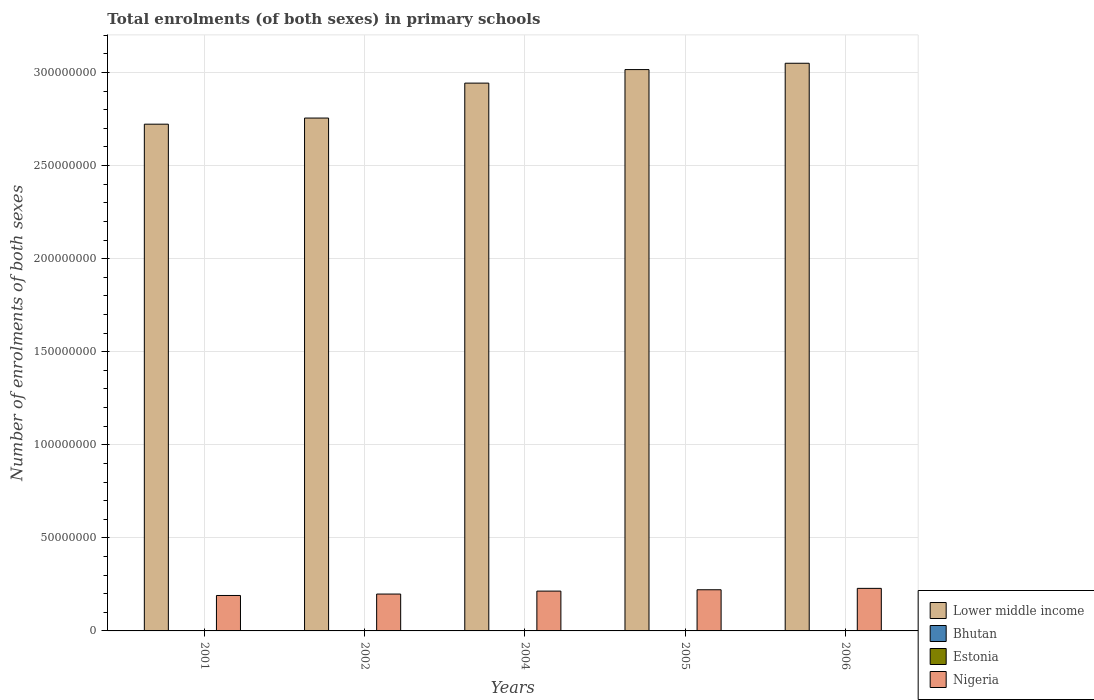Are the number of bars on each tick of the X-axis equal?
Give a very brief answer. Yes. How many bars are there on the 3rd tick from the left?
Provide a succinct answer. 4. What is the label of the 1st group of bars from the left?
Make the answer very short. 2001. What is the number of enrolments in primary schools in Estonia in 2004?
Offer a very short reply. 9.21e+04. Across all years, what is the maximum number of enrolments in primary schools in Lower middle income?
Provide a short and direct response. 3.05e+08. Across all years, what is the minimum number of enrolments in primary schools in Estonia?
Offer a very short reply. 7.96e+04. In which year was the number of enrolments in primary schools in Nigeria minimum?
Your answer should be compact. 2001. What is the total number of enrolments in primary schools in Nigeria in the graph?
Your answer should be compact. 1.05e+08. What is the difference between the number of enrolments in primary schools in Lower middle income in 2004 and that in 2006?
Offer a terse response. -1.07e+07. What is the difference between the number of enrolments in primary schools in Nigeria in 2001 and the number of enrolments in primary schools in Estonia in 2004?
Give a very brief answer. 1.89e+07. What is the average number of enrolments in primary schools in Estonia per year?
Provide a short and direct response. 9.66e+04. In the year 2004, what is the difference between the number of enrolments in primary schools in Estonia and number of enrolments in primary schools in Bhutan?
Your answer should be compact. -5225. In how many years, is the number of enrolments in primary schools in Bhutan greater than 270000000?
Ensure brevity in your answer.  0. What is the ratio of the number of enrolments in primary schools in Bhutan in 2001 to that in 2004?
Make the answer very short. 0.91. Is the difference between the number of enrolments in primary schools in Estonia in 2001 and 2002 greater than the difference between the number of enrolments in primary schools in Bhutan in 2001 and 2002?
Your answer should be very brief. Yes. What is the difference between the highest and the second highest number of enrolments in primary schools in Nigeria?
Your answer should be very brief. 7.46e+05. What is the difference between the highest and the lowest number of enrolments in primary schools in Nigeria?
Offer a very short reply. 3.82e+06. In how many years, is the number of enrolments in primary schools in Nigeria greater than the average number of enrolments in primary schools in Nigeria taken over all years?
Ensure brevity in your answer.  3. Is the sum of the number of enrolments in primary schools in Nigeria in 2002 and 2006 greater than the maximum number of enrolments in primary schools in Estonia across all years?
Provide a succinct answer. Yes. Is it the case that in every year, the sum of the number of enrolments in primary schools in Bhutan and number of enrolments in primary schools in Estonia is greater than the sum of number of enrolments in primary schools in Lower middle income and number of enrolments in primary schools in Nigeria?
Your response must be concise. Yes. What does the 4th bar from the left in 2004 represents?
Keep it short and to the point. Nigeria. What does the 4th bar from the right in 2005 represents?
Offer a terse response. Lower middle income. Is it the case that in every year, the sum of the number of enrolments in primary schools in Lower middle income and number of enrolments in primary schools in Bhutan is greater than the number of enrolments in primary schools in Estonia?
Make the answer very short. Yes. Are all the bars in the graph horizontal?
Provide a short and direct response. No. How many years are there in the graph?
Give a very brief answer. 5. Are the values on the major ticks of Y-axis written in scientific E-notation?
Your answer should be compact. No. Does the graph contain grids?
Give a very brief answer. Yes. How many legend labels are there?
Keep it short and to the point. 4. How are the legend labels stacked?
Your answer should be very brief. Vertical. What is the title of the graph?
Your answer should be compact. Total enrolments (of both sexes) in primary schools. What is the label or title of the X-axis?
Your answer should be very brief. Years. What is the label or title of the Y-axis?
Your answer should be compact. Number of enrolments of both sexes. What is the Number of enrolments of both sexes in Lower middle income in 2001?
Ensure brevity in your answer.  2.72e+08. What is the Number of enrolments of both sexes in Bhutan in 2001?
Provide a short and direct response. 8.82e+04. What is the Number of enrolments of both sexes in Estonia in 2001?
Offer a very short reply. 1.17e+05. What is the Number of enrolments of both sexes in Nigeria in 2001?
Offer a very short reply. 1.90e+07. What is the Number of enrolments of both sexes in Lower middle income in 2002?
Your response must be concise. 2.76e+08. What is the Number of enrolments of both sexes in Bhutan in 2002?
Ensure brevity in your answer.  9.09e+04. What is the Number of enrolments of both sexes in Estonia in 2002?
Make the answer very short. 1.09e+05. What is the Number of enrolments of both sexes in Nigeria in 2002?
Offer a very short reply. 1.98e+07. What is the Number of enrolments of both sexes in Lower middle income in 2004?
Provide a short and direct response. 2.94e+08. What is the Number of enrolments of both sexes of Bhutan in 2004?
Provide a succinct answer. 9.73e+04. What is the Number of enrolments of both sexes of Estonia in 2004?
Ensure brevity in your answer.  9.21e+04. What is the Number of enrolments of both sexes of Nigeria in 2004?
Keep it short and to the point. 2.14e+07. What is the Number of enrolments of both sexes of Lower middle income in 2005?
Your answer should be compact. 3.02e+08. What is the Number of enrolments of both sexes of Bhutan in 2005?
Your answer should be compact. 9.95e+04. What is the Number of enrolments of both sexes of Estonia in 2005?
Your answer should be compact. 8.55e+04. What is the Number of enrolments of both sexes in Nigeria in 2005?
Make the answer very short. 2.21e+07. What is the Number of enrolments of both sexes in Lower middle income in 2006?
Provide a succinct answer. 3.05e+08. What is the Number of enrolments of both sexes of Bhutan in 2006?
Your answer should be compact. 1.02e+05. What is the Number of enrolments of both sexes of Estonia in 2006?
Your response must be concise. 7.96e+04. What is the Number of enrolments of both sexes of Nigeria in 2006?
Provide a succinct answer. 2.29e+07. Across all years, what is the maximum Number of enrolments of both sexes of Lower middle income?
Provide a short and direct response. 3.05e+08. Across all years, what is the maximum Number of enrolments of both sexes of Bhutan?
Ensure brevity in your answer.  1.02e+05. Across all years, what is the maximum Number of enrolments of both sexes in Estonia?
Offer a terse response. 1.17e+05. Across all years, what is the maximum Number of enrolments of both sexes in Nigeria?
Provide a short and direct response. 2.29e+07. Across all years, what is the minimum Number of enrolments of both sexes of Lower middle income?
Offer a terse response. 2.72e+08. Across all years, what is the minimum Number of enrolments of both sexes in Bhutan?
Provide a succinct answer. 8.82e+04. Across all years, what is the minimum Number of enrolments of both sexes of Estonia?
Make the answer very short. 7.96e+04. Across all years, what is the minimum Number of enrolments of both sexes in Nigeria?
Make the answer very short. 1.90e+07. What is the total Number of enrolments of both sexes in Lower middle income in the graph?
Your answer should be very brief. 1.45e+09. What is the total Number of enrolments of both sexes in Bhutan in the graph?
Give a very brief answer. 4.78e+05. What is the total Number of enrolments of both sexes in Estonia in the graph?
Offer a very short reply. 4.83e+05. What is the total Number of enrolments of both sexes in Nigeria in the graph?
Offer a terse response. 1.05e+08. What is the difference between the Number of enrolments of both sexes in Lower middle income in 2001 and that in 2002?
Provide a short and direct response. -3.29e+06. What is the difference between the Number of enrolments of both sexes in Bhutan in 2001 and that in 2002?
Ensure brevity in your answer.  -2740. What is the difference between the Number of enrolments of both sexes in Estonia in 2001 and that in 2002?
Offer a very short reply. 8652. What is the difference between the Number of enrolments of both sexes in Nigeria in 2001 and that in 2002?
Your answer should be compact. -7.65e+05. What is the difference between the Number of enrolments of both sexes in Lower middle income in 2001 and that in 2004?
Your answer should be very brief. -2.21e+07. What is the difference between the Number of enrolments of both sexes in Bhutan in 2001 and that in 2004?
Ensure brevity in your answer.  -9119. What is the difference between the Number of enrolments of both sexes in Estonia in 2001 and that in 2004?
Give a very brief answer. 2.52e+04. What is the difference between the Number of enrolments of both sexes in Nigeria in 2001 and that in 2004?
Your response must be concise. -2.35e+06. What is the difference between the Number of enrolments of both sexes in Lower middle income in 2001 and that in 2005?
Your answer should be compact. -2.93e+07. What is the difference between the Number of enrolments of both sexes in Bhutan in 2001 and that in 2005?
Offer a very short reply. -1.13e+04. What is the difference between the Number of enrolments of both sexes in Estonia in 2001 and that in 2005?
Ensure brevity in your answer.  3.18e+04. What is the difference between the Number of enrolments of both sexes of Nigeria in 2001 and that in 2005?
Your answer should be compact. -3.07e+06. What is the difference between the Number of enrolments of both sexes of Lower middle income in 2001 and that in 2006?
Offer a terse response. -3.27e+07. What is the difference between the Number of enrolments of both sexes in Bhutan in 2001 and that in 2006?
Offer a very short reply. -1.40e+04. What is the difference between the Number of enrolments of both sexes of Estonia in 2001 and that in 2006?
Your response must be concise. 3.77e+04. What is the difference between the Number of enrolments of both sexes of Nigeria in 2001 and that in 2006?
Make the answer very short. -3.82e+06. What is the difference between the Number of enrolments of both sexes of Lower middle income in 2002 and that in 2004?
Your answer should be compact. -1.88e+07. What is the difference between the Number of enrolments of both sexes of Bhutan in 2002 and that in 2004?
Your answer should be compact. -6379. What is the difference between the Number of enrolments of both sexes of Estonia in 2002 and that in 2004?
Make the answer very short. 1.65e+04. What is the difference between the Number of enrolments of both sexes in Nigeria in 2002 and that in 2004?
Make the answer very short. -1.59e+06. What is the difference between the Number of enrolments of both sexes of Lower middle income in 2002 and that in 2005?
Keep it short and to the point. -2.60e+07. What is the difference between the Number of enrolments of both sexes of Bhutan in 2002 and that in 2005?
Provide a succinct answer. -8514. What is the difference between the Number of enrolments of both sexes of Estonia in 2002 and that in 2005?
Provide a short and direct response. 2.31e+04. What is the difference between the Number of enrolments of both sexes in Nigeria in 2002 and that in 2005?
Provide a succinct answer. -2.31e+06. What is the difference between the Number of enrolments of both sexes in Lower middle income in 2002 and that in 2006?
Keep it short and to the point. -2.94e+07. What is the difference between the Number of enrolments of both sexes in Bhutan in 2002 and that in 2006?
Your answer should be very brief. -1.13e+04. What is the difference between the Number of enrolments of both sexes of Estonia in 2002 and that in 2006?
Ensure brevity in your answer.  2.90e+04. What is the difference between the Number of enrolments of both sexes of Nigeria in 2002 and that in 2006?
Provide a short and direct response. -3.06e+06. What is the difference between the Number of enrolments of both sexes of Lower middle income in 2004 and that in 2005?
Offer a very short reply. -7.27e+06. What is the difference between the Number of enrolments of both sexes of Bhutan in 2004 and that in 2005?
Keep it short and to the point. -2135. What is the difference between the Number of enrolments of both sexes of Estonia in 2004 and that in 2005?
Provide a succinct answer. 6559. What is the difference between the Number of enrolments of both sexes of Nigeria in 2004 and that in 2005?
Your answer should be very brief. -7.20e+05. What is the difference between the Number of enrolments of both sexes of Lower middle income in 2004 and that in 2006?
Offer a terse response. -1.07e+07. What is the difference between the Number of enrolments of both sexes in Bhutan in 2004 and that in 2006?
Keep it short and to the point. -4902. What is the difference between the Number of enrolments of both sexes in Estonia in 2004 and that in 2006?
Ensure brevity in your answer.  1.25e+04. What is the difference between the Number of enrolments of both sexes in Nigeria in 2004 and that in 2006?
Keep it short and to the point. -1.47e+06. What is the difference between the Number of enrolments of both sexes in Lower middle income in 2005 and that in 2006?
Offer a very short reply. -3.40e+06. What is the difference between the Number of enrolments of both sexes of Bhutan in 2005 and that in 2006?
Give a very brief answer. -2767. What is the difference between the Number of enrolments of both sexes of Estonia in 2005 and that in 2006?
Your answer should be compact. 5950. What is the difference between the Number of enrolments of both sexes in Nigeria in 2005 and that in 2006?
Provide a succinct answer. -7.46e+05. What is the difference between the Number of enrolments of both sexes of Lower middle income in 2001 and the Number of enrolments of both sexes of Bhutan in 2002?
Offer a very short reply. 2.72e+08. What is the difference between the Number of enrolments of both sexes of Lower middle income in 2001 and the Number of enrolments of both sexes of Estonia in 2002?
Your answer should be compact. 2.72e+08. What is the difference between the Number of enrolments of both sexes of Lower middle income in 2001 and the Number of enrolments of both sexes of Nigeria in 2002?
Offer a very short reply. 2.52e+08. What is the difference between the Number of enrolments of both sexes in Bhutan in 2001 and the Number of enrolments of both sexes in Estonia in 2002?
Your response must be concise. -2.04e+04. What is the difference between the Number of enrolments of both sexes of Bhutan in 2001 and the Number of enrolments of both sexes of Nigeria in 2002?
Provide a short and direct response. -1.97e+07. What is the difference between the Number of enrolments of both sexes in Estonia in 2001 and the Number of enrolments of both sexes in Nigeria in 2002?
Keep it short and to the point. -1.97e+07. What is the difference between the Number of enrolments of both sexes of Lower middle income in 2001 and the Number of enrolments of both sexes of Bhutan in 2004?
Provide a short and direct response. 2.72e+08. What is the difference between the Number of enrolments of both sexes in Lower middle income in 2001 and the Number of enrolments of both sexes in Estonia in 2004?
Provide a short and direct response. 2.72e+08. What is the difference between the Number of enrolments of both sexes in Lower middle income in 2001 and the Number of enrolments of both sexes in Nigeria in 2004?
Give a very brief answer. 2.51e+08. What is the difference between the Number of enrolments of both sexes in Bhutan in 2001 and the Number of enrolments of both sexes in Estonia in 2004?
Give a very brief answer. -3894. What is the difference between the Number of enrolments of both sexes of Bhutan in 2001 and the Number of enrolments of both sexes of Nigeria in 2004?
Make the answer very short. -2.13e+07. What is the difference between the Number of enrolments of both sexes of Estonia in 2001 and the Number of enrolments of both sexes of Nigeria in 2004?
Make the answer very short. -2.13e+07. What is the difference between the Number of enrolments of both sexes in Lower middle income in 2001 and the Number of enrolments of both sexes in Bhutan in 2005?
Your answer should be very brief. 2.72e+08. What is the difference between the Number of enrolments of both sexes in Lower middle income in 2001 and the Number of enrolments of both sexes in Estonia in 2005?
Make the answer very short. 2.72e+08. What is the difference between the Number of enrolments of both sexes of Lower middle income in 2001 and the Number of enrolments of both sexes of Nigeria in 2005?
Ensure brevity in your answer.  2.50e+08. What is the difference between the Number of enrolments of both sexes of Bhutan in 2001 and the Number of enrolments of both sexes of Estonia in 2005?
Provide a succinct answer. 2665. What is the difference between the Number of enrolments of both sexes in Bhutan in 2001 and the Number of enrolments of both sexes in Nigeria in 2005?
Your answer should be compact. -2.20e+07. What is the difference between the Number of enrolments of both sexes in Estonia in 2001 and the Number of enrolments of both sexes in Nigeria in 2005?
Your response must be concise. -2.20e+07. What is the difference between the Number of enrolments of both sexes in Lower middle income in 2001 and the Number of enrolments of both sexes in Bhutan in 2006?
Keep it short and to the point. 2.72e+08. What is the difference between the Number of enrolments of both sexes of Lower middle income in 2001 and the Number of enrolments of both sexes of Estonia in 2006?
Your answer should be very brief. 2.72e+08. What is the difference between the Number of enrolments of both sexes of Lower middle income in 2001 and the Number of enrolments of both sexes of Nigeria in 2006?
Offer a terse response. 2.49e+08. What is the difference between the Number of enrolments of both sexes of Bhutan in 2001 and the Number of enrolments of both sexes of Estonia in 2006?
Give a very brief answer. 8615. What is the difference between the Number of enrolments of both sexes of Bhutan in 2001 and the Number of enrolments of both sexes of Nigeria in 2006?
Give a very brief answer. -2.28e+07. What is the difference between the Number of enrolments of both sexes in Estonia in 2001 and the Number of enrolments of both sexes in Nigeria in 2006?
Your answer should be very brief. -2.27e+07. What is the difference between the Number of enrolments of both sexes in Lower middle income in 2002 and the Number of enrolments of both sexes in Bhutan in 2004?
Provide a succinct answer. 2.75e+08. What is the difference between the Number of enrolments of both sexes in Lower middle income in 2002 and the Number of enrolments of both sexes in Estonia in 2004?
Offer a terse response. 2.75e+08. What is the difference between the Number of enrolments of both sexes of Lower middle income in 2002 and the Number of enrolments of both sexes of Nigeria in 2004?
Your answer should be compact. 2.54e+08. What is the difference between the Number of enrolments of both sexes in Bhutan in 2002 and the Number of enrolments of both sexes in Estonia in 2004?
Give a very brief answer. -1154. What is the difference between the Number of enrolments of both sexes in Bhutan in 2002 and the Number of enrolments of both sexes in Nigeria in 2004?
Offer a very short reply. -2.13e+07. What is the difference between the Number of enrolments of both sexes in Estonia in 2002 and the Number of enrolments of both sexes in Nigeria in 2004?
Ensure brevity in your answer.  -2.13e+07. What is the difference between the Number of enrolments of both sexes of Lower middle income in 2002 and the Number of enrolments of both sexes of Bhutan in 2005?
Offer a terse response. 2.75e+08. What is the difference between the Number of enrolments of both sexes in Lower middle income in 2002 and the Number of enrolments of both sexes in Estonia in 2005?
Ensure brevity in your answer.  2.75e+08. What is the difference between the Number of enrolments of both sexes of Lower middle income in 2002 and the Number of enrolments of both sexes of Nigeria in 2005?
Offer a terse response. 2.53e+08. What is the difference between the Number of enrolments of both sexes of Bhutan in 2002 and the Number of enrolments of both sexes of Estonia in 2005?
Ensure brevity in your answer.  5405. What is the difference between the Number of enrolments of both sexes of Bhutan in 2002 and the Number of enrolments of both sexes of Nigeria in 2005?
Give a very brief answer. -2.20e+07. What is the difference between the Number of enrolments of both sexes of Estonia in 2002 and the Number of enrolments of both sexes of Nigeria in 2005?
Your response must be concise. -2.20e+07. What is the difference between the Number of enrolments of both sexes of Lower middle income in 2002 and the Number of enrolments of both sexes of Bhutan in 2006?
Keep it short and to the point. 2.75e+08. What is the difference between the Number of enrolments of both sexes in Lower middle income in 2002 and the Number of enrolments of both sexes in Estonia in 2006?
Your answer should be very brief. 2.75e+08. What is the difference between the Number of enrolments of both sexes in Lower middle income in 2002 and the Number of enrolments of both sexes in Nigeria in 2006?
Your answer should be compact. 2.53e+08. What is the difference between the Number of enrolments of both sexes in Bhutan in 2002 and the Number of enrolments of both sexes in Estonia in 2006?
Offer a terse response. 1.14e+04. What is the difference between the Number of enrolments of both sexes of Bhutan in 2002 and the Number of enrolments of both sexes of Nigeria in 2006?
Give a very brief answer. -2.28e+07. What is the difference between the Number of enrolments of both sexes of Estonia in 2002 and the Number of enrolments of both sexes of Nigeria in 2006?
Ensure brevity in your answer.  -2.28e+07. What is the difference between the Number of enrolments of both sexes in Lower middle income in 2004 and the Number of enrolments of both sexes in Bhutan in 2005?
Make the answer very short. 2.94e+08. What is the difference between the Number of enrolments of both sexes in Lower middle income in 2004 and the Number of enrolments of both sexes in Estonia in 2005?
Ensure brevity in your answer.  2.94e+08. What is the difference between the Number of enrolments of both sexes of Lower middle income in 2004 and the Number of enrolments of both sexes of Nigeria in 2005?
Your answer should be very brief. 2.72e+08. What is the difference between the Number of enrolments of both sexes in Bhutan in 2004 and the Number of enrolments of both sexes in Estonia in 2005?
Provide a short and direct response. 1.18e+04. What is the difference between the Number of enrolments of both sexes of Bhutan in 2004 and the Number of enrolments of both sexes of Nigeria in 2005?
Give a very brief answer. -2.20e+07. What is the difference between the Number of enrolments of both sexes of Estonia in 2004 and the Number of enrolments of both sexes of Nigeria in 2005?
Provide a succinct answer. -2.20e+07. What is the difference between the Number of enrolments of both sexes in Lower middle income in 2004 and the Number of enrolments of both sexes in Bhutan in 2006?
Your answer should be very brief. 2.94e+08. What is the difference between the Number of enrolments of both sexes in Lower middle income in 2004 and the Number of enrolments of both sexes in Estonia in 2006?
Your answer should be very brief. 2.94e+08. What is the difference between the Number of enrolments of both sexes in Lower middle income in 2004 and the Number of enrolments of both sexes in Nigeria in 2006?
Make the answer very short. 2.71e+08. What is the difference between the Number of enrolments of both sexes of Bhutan in 2004 and the Number of enrolments of both sexes of Estonia in 2006?
Give a very brief answer. 1.77e+04. What is the difference between the Number of enrolments of both sexes of Bhutan in 2004 and the Number of enrolments of both sexes of Nigeria in 2006?
Your answer should be very brief. -2.28e+07. What is the difference between the Number of enrolments of both sexes in Estonia in 2004 and the Number of enrolments of both sexes in Nigeria in 2006?
Your response must be concise. -2.28e+07. What is the difference between the Number of enrolments of both sexes in Lower middle income in 2005 and the Number of enrolments of both sexes in Bhutan in 2006?
Make the answer very short. 3.01e+08. What is the difference between the Number of enrolments of both sexes of Lower middle income in 2005 and the Number of enrolments of both sexes of Estonia in 2006?
Provide a short and direct response. 3.02e+08. What is the difference between the Number of enrolments of both sexes in Lower middle income in 2005 and the Number of enrolments of both sexes in Nigeria in 2006?
Offer a terse response. 2.79e+08. What is the difference between the Number of enrolments of both sexes of Bhutan in 2005 and the Number of enrolments of both sexes of Estonia in 2006?
Your answer should be very brief. 1.99e+04. What is the difference between the Number of enrolments of both sexes in Bhutan in 2005 and the Number of enrolments of both sexes in Nigeria in 2006?
Your answer should be compact. -2.28e+07. What is the difference between the Number of enrolments of both sexes in Estonia in 2005 and the Number of enrolments of both sexes in Nigeria in 2006?
Give a very brief answer. -2.28e+07. What is the average Number of enrolments of both sexes of Lower middle income per year?
Your answer should be very brief. 2.90e+08. What is the average Number of enrolments of both sexes in Bhutan per year?
Provide a succinct answer. 9.56e+04. What is the average Number of enrolments of both sexes of Estonia per year?
Give a very brief answer. 9.66e+04. What is the average Number of enrolments of both sexes in Nigeria per year?
Give a very brief answer. 2.10e+07. In the year 2001, what is the difference between the Number of enrolments of both sexes of Lower middle income and Number of enrolments of both sexes of Bhutan?
Offer a terse response. 2.72e+08. In the year 2001, what is the difference between the Number of enrolments of both sexes in Lower middle income and Number of enrolments of both sexes in Estonia?
Your response must be concise. 2.72e+08. In the year 2001, what is the difference between the Number of enrolments of both sexes of Lower middle income and Number of enrolments of both sexes of Nigeria?
Your answer should be compact. 2.53e+08. In the year 2001, what is the difference between the Number of enrolments of both sexes of Bhutan and Number of enrolments of both sexes of Estonia?
Provide a short and direct response. -2.91e+04. In the year 2001, what is the difference between the Number of enrolments of both sexes of Bhutan and Number of enrolments of both sexes of Nigeria?
Make the answer very short. -1.90e+07. In the year 2001, what is the difference between the Number of enrolments of both sexes in Estonia and Number of enrolments of both sexes in Nigeria?
Your answer should be compact. -1.89e+07. In the year 2002, what is the difference between the Number of enrolments of both sexes of Lower middle income and Number of enrolments of both sexes of Bhutan?
Offer a very short reply. 2.75e+08. In the year 2002, what is the difference between the Number of enrolments of both sexes in Lower middle income and Number of enrolments of both sexes in Estonia?
Give a very brief answer. 2.75e+08. In the year 2002, what is the difference between the Number of enrolments of both sexes in Lower middle income and Number of enrolments of both sexes in Nigeria?
Offer a very short reply. 2.56e+08. In the year 2002, what is the difference between the Number of enrolments of both sexes of Bhutan and Number of enrolments of both sexes of Estonia?
Give a very brief answer. -1.77e+04. In the year 2002, what is the difference between the Number of enrolments of both sexes of Bhutan and Number of enrolments of both sexes of Nigeria?
Provide a succinct answer. -1.97e+07. In the year 2002, what is the difference between the Number of enrolments of both sexes of Estonia and Number of enrolments of both sexes of Nigeria?
Your answer should be compact. -1.97e+07. In the year 2004, what is the difference between the Number of enrolments of both sexes in Lower middle income and Number of enrolments of both sexes in Bhutan?
Offer a terse response. 2.94e+08. In the year 2004, what is the difference between the Number of enrolments of both sexes of Lower middle income and Number of enrolments of both sexes of Estonia?
Your response must be concise. 2.94e+08. In the year 2004, what is the difference between the Number of enrolments of both sexes in Lower middle income and Number of enrolments of both sexes in Nigeria?
Your answer should be compact. 2.73e+08. In the year 2004, what is the difference between the Number of enrolments of both sexes in Bhutan and Number of enrolments of both sexes in Estonia?
Provide a succinct answer. 5225. In the year 2004, what is the difference between the Number of enrolments of both sexes of Bhutan and Number of enrolments of both sexes of Nigeria?
Your answer should be compact. -2.13e+07. In the year 2004, what is the difference between the Number of enrolments of both sexes of Estonia and Number of enrolments of both sexes of Nigeria?
Provide a short and direct response. -2.13e+07. In the year 2005, what is the difference between the Number of enrolments of both sexes of Lower middle income and Number of enrolments of both sexes of Bhutan?
Your answer should be compact. 3.01e+08. In the year 2005, what is the difference between the Number of enrolments of both sexes in Lower middle income and Number of enrolments of both sexes in Estonia?
Give a very brief answer. 3.02e+08. In the year 2005, what is the difference between the Number of enrolments of both sexes in Lower middle income and Number of enrolments of both sexes in Nigeria?
Ensure brevity in your answer.  2.79e+08. In the year 2005, what is the difference between the Number of enrolments of both sexes of Bhutan and Number of enrolments of both sexes of Estonia?
Keep it short and to the point. 1.39e+04. In the year 2005, what is the difference between the Number of enrolments of both sexes in Bhutan and Number of enrolments of both sexes in Nigeria?
Offer a very short reply. -2.20e+07. In the year 2005, what is the difference between the Number of enrolments of both sexes in Estonia and Number of enrolments of both sexes in Nigeria?
Your answer should be very brief. -2.20e+07. In the year 2006, what is the difference between the Number of enrolments of both sexes of Lower middle income and Number of enrolments of both sexes of Bhutan?
Your answer should be very brief. 3.05e+08. In the year 2006, what is the difference between the Number of enrolments of both sexes in Lower middle income and Number of enrolments of both sexes in Estonia?
Your answer should be compact. 3.05e+08. In the year 2006, what is the difference between the Number of enrolments of both sexes in Lower middle income and Number of enrolments of both sexes in Nigeria?
Keep it short and to the point. 2.82e+08. In the year 2006, what is the difference between the Number of enrolments of both sexes of Bhutan and Number of enrolments of both sexes of Estonia?
Provide a short and direct response. 2.26e+04. In the year 2006, what is the difference between the Number of enrolments of both sexes of Bhutan and Number of enrolments of both sexes of Nigeria?
Offer a terse response. -2.28e+07. In the year 2006, what is the difference between the Number of enrolments of both sexes in Estonia and Number of enrolments of both sexes in Nigeria?
Make the answer very short. -2.28e+07. What is the ratio of the Number of enrolments of both sexes of Bhutan in 2001 to that in 2002?
Make the answer very short. 0.97. What is the ratio of the Number of enrolments of both sexes of Estonia in 2001 to that in 2002?
Offer a very short reply. 1.08. What is the ratio of the Number of enrolments of both sexes of Nigeria in 2001 to that in 2002?
Make the answer very short. 0.96. What is the ratio of the Number of enrolments of both sexes of Lower middle income in 2001 to that in 2004?
Provide a succinct answer. 0.93. What is the ratio of the Number of enrolments of both sexes of Bhutan in 2001 to that in 2004?
Offer a terse response. 0.91. What is the ratio of the Number of enrolments of both sexes of Estonia in 2001 to that in 2004?
Your response must be concise. 1.27. What is the ratio of the Number of enrolments of both sexes of Nigeria in 2001 to that in 2004?
Your answer should be compact. 0.89. What is the ratio of the Number of enrolments of both sexes in Lower middle income in 2001 to that in 2005?
Make the answer very short. 0.9. What is the ratio of the Number of enrolments of both sexes in Bhutan in 2001 to that in 2005?
Ensure brevity in your answer.  0.89. What is the ratio of the Number of enrolments of both sexes of Estonia in 2001 to that in 2005?
Keep it short and to the point. 1.37. What is the ratio of the Number of enrolments of both sexes of Nigeria in 2001 to that in 2005?
Your answer should be compact. 0.86. What is the ratio of the Number of enrolments of both sexes in Lower middle income in 2001 to that in 2006?
Provide a short and direct response. 0.89. What is the ratio of the Number of enrolments of both sexes in Bhutan in 2001 to that in 2006?
Ensure brevity in your answer.  0.86. What is the ratio of the Number of enrolments of both sexes in Estonia in 2001 to that in 2006?
Provide a short and direct response. 1.47. What is the ratio of the Number of enrolments of both sexes of Nigeria in 2001 to that in 2006?
Your response must be concise. 0.83. What is the ratio of the Number of enrolments of both sexes in Lower middle income in 2002 to that in 2004?
Your answer should be very brief. 0.94. What is the ratio of the Number of enrolments of both sexes of Bhutan in 2002 to that in 2004?
Make the answer very short. 0.93. What is the ratio of the Number of enrolments of both sexes of Estonia in 2002 to that in 2004?
Offer a terse response. 1.18. What is the ratio of the Number of enrolments of both sexes of Nigeria in 2002 to that in 2004?
Give a very brief answer. 0.93. What is the ratio of the Number of enrolments of both sexes of Lower middle income in 2002 to that in 2005?
Offer a terse response. 0.91. What is the ratio of the Number of enrolments of both sexes in Bhutan in 2002 to that in 2005?
Your answer should be compact. 0.91. What is the ratio of the Number of enrolments of both sexes in Estonia in 2002 to that in 2005?
Offer a very short reply. 1.27. What is the ratio of the Number of enrolments of both sexes of Nigeria in 2002 to that in 2005?
Give a very brief answer. 0.9. What is the ratio of the Number of enrolments of both sexes in Lower middle income in 2002 to that in 2006?
Your answer should be compact. 0.9. What is the ratio of the Number of enrolments of both sexes of Bhutan in 2002 to that in 2006?
Provide a short and direct response. 0.89. What is the ratio of the Number of enrolments of both sexes in Estonia in 2002 to that in 2006?
Give a very brief answer. 1.36. What is the ratio of the Number of enrolments of both sexes of Nigeria in 2002 to that in 2006?
Give a very brief answer. 0.87. What is the ratio of the Number of enrolments of both sexes in Lower middle income in 2004 to that in 2005?
Give a very brief answer. 0.98. What is the ratio of the Number of enrolments of both sexes in Bhutan in 2004 to that in 2005?
Provide a short and direct response. 0.98. What is the ratio of the Number of enrolments of both sexes in Estonia in 2004 to that in 2005?
Your response must be concise. 1.08. What is the ratio of the Number of enrolments of both sexes of Nigeria in 2004 to that in 2005?
Offer a very short reply. 0.97. What is the ratio of the Number of enrolments of both sexes of Estonia in 2004 to that in 2006?
Give a very brief answer. 1.16. What is the ratio of the Number of enrolments of both sexes of Nigeria in 2004 to that in 2006?
Your answer should be very brief. 0.94. What is the ratio of the Number of enrolments of both sexes in Lower middle income in 2005 to that in 2006?
Your answer should be very brief. 0.99. What is the ratio of the Number of enrolments of both sexes of Bhutan in 2005 to that in 2006?
Keep it short and to the point. 0.97. What is the ratio of the Number of enrolments of both sexes of Estonia in 2005 to that in 2006?
Your answer should be compact. 1.07. What is the ratio of the Number of enrolments of both sexes in Nigeria in 2005 to that in 2006?
Your answer should be compact. 0.97. What is the difference between the highest and the second highest Number of enrolments of both sexes of Lower middle income?
Offer a terse response. 3.40e+06. What is the difference between the highest and the second highest Number of enrolments of both sexes in Bhutan?
Your answer should be compact. 2767. What is the difference between the highest and the second highest Number of enrolments of both sexes of Estonia?
Provide a succinct answer. 8652. What is the difference between the highest and the second highest Number of enrolments of both sexes in Nigeria?
Ensure brevity in your answer.  7.46e+05. What is the difference between the highest and the lowest Number of enrolments of both sexes of Lower middle income?
Make the answer very short. 3.27e+07. What is the difference between the highest and the lowest Number of enrolments of both sexes of Bhutan?
Make the answer very short. 1.40e+04. What is the difference between the highest and the lowest Number of enrolments of both sexes of Estonia?
Keep it short and to the point. 3.77e+04. What is the difference between the highest and the lowest Number of enrolments of both sexes of Nigeria?
Keep it short and to the point. 3.82e+06. 